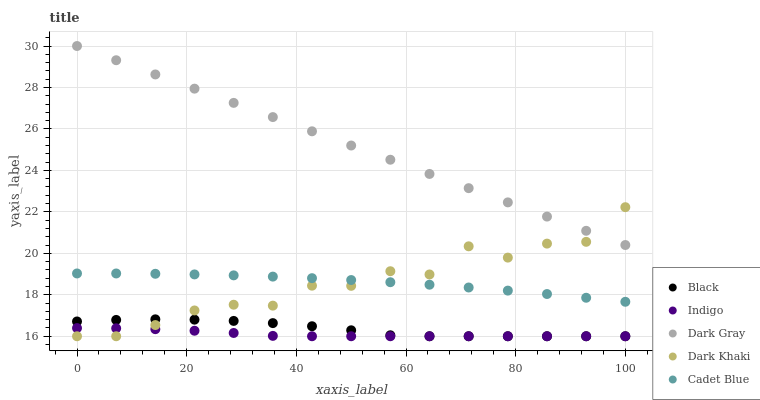Does Indigo have the minimum area under the curve?
Answer yes or no. Yes. Does Dark Gray have the maximum area under the curve?
Answer yes or no. Yes. Does Cadet Blue have the minimum area under the curve?
Answer yes or no. No. Does Cadet Blue have the maximum area under the curve?
Answer yes or no. No. Is Dark Gray the smoothest?
Answer yes or no. Yes. Is Dark Khaki the roughest?
Answer yes or no. Yes. Is Indigo the smoothest?
Answer yes or no. No. Is Indigo the roughest?
Answer yes or no. No. Does Indigo have the lowest value?
Answer yes or no. Yes. Does Cadet Blue have the lowest value?
Answer yes or no. No. Does Dark Gray have the highest value?
Answer yes or no. Yes. Does Cadet Blue have the highest value?
Answer yes or no. No. Is Cadet Blue less than Dark Gray?
Answer yes or no. Yes. Is Dark Gray greater than Cadet Blue?
Answer yes or no. Yes. Does Dark Khaki intersect Dark Gray?
Answer yes or no. Yes. Is Dark Khaki less than Dark Gray?
Answer yes or no. No. Is Dark Khaki greater than Dark Gray?
Answer yes or no. No. Does Cadet Blue intersect Dark Gray?
Answer yes or no. No. 